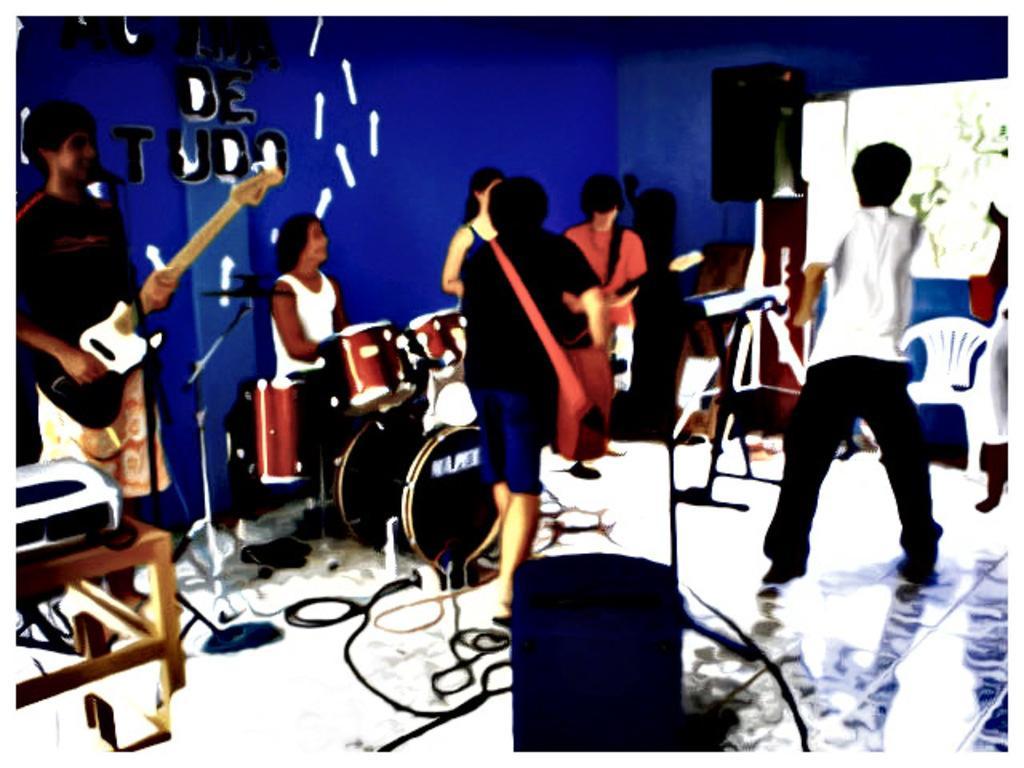How would you summarize this image in a sentence or two? As we can see in the image there are few people here and there, sound box, projector, screen, chairs. On the left side there is a man holding guitar and there is blue color wall. 